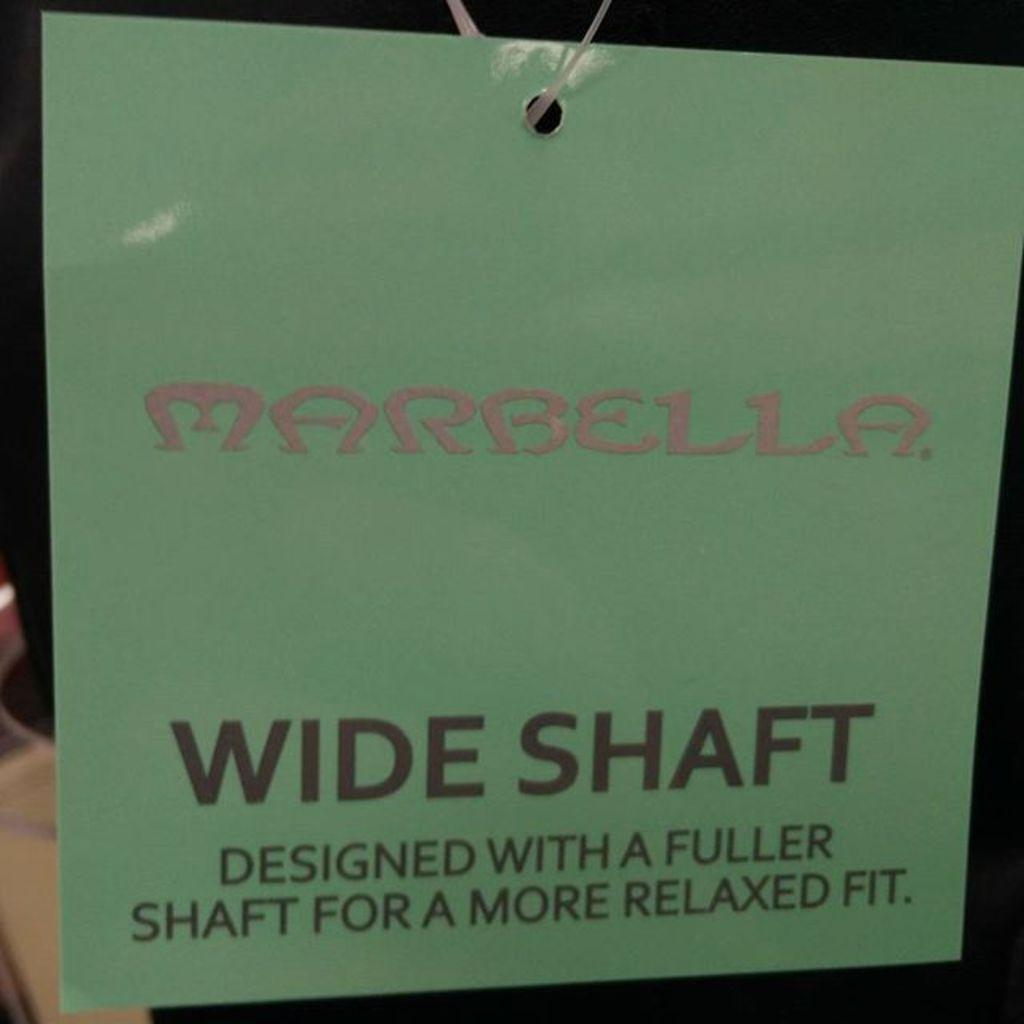<image>
Write a terse but informative summary of the picture. Hanging green sign that says "Marbella" in pink. 